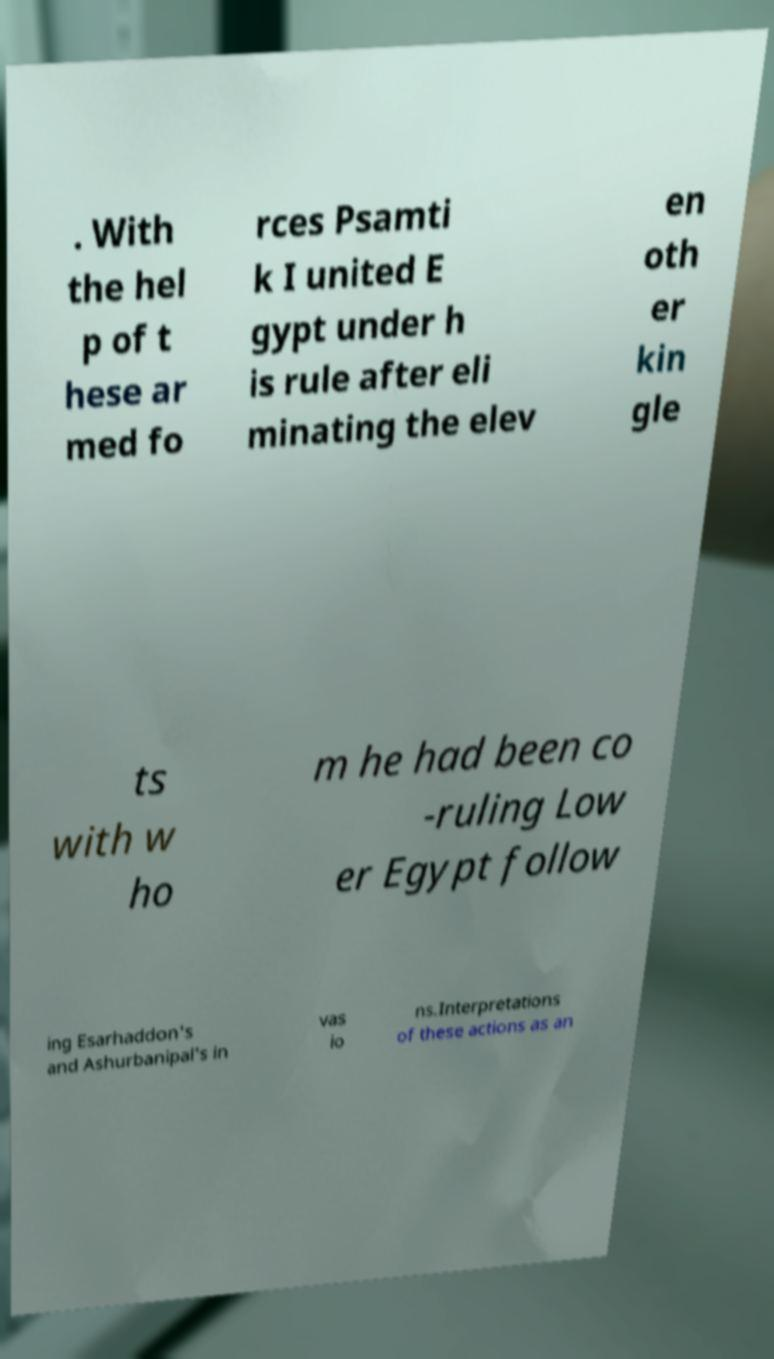I need the written content from this picture converted into text. Can you do that? . With the hel p of t hese ar med fo rces Psamti k I united E gypt under h is rule after eli minating the elev en oth er kin gle ts with w ho m he had been co -ruling Low er Egypt follow ing Esarhaddon's and Ashurbanipal's in vas io ns.Interpretations of these actions as an 